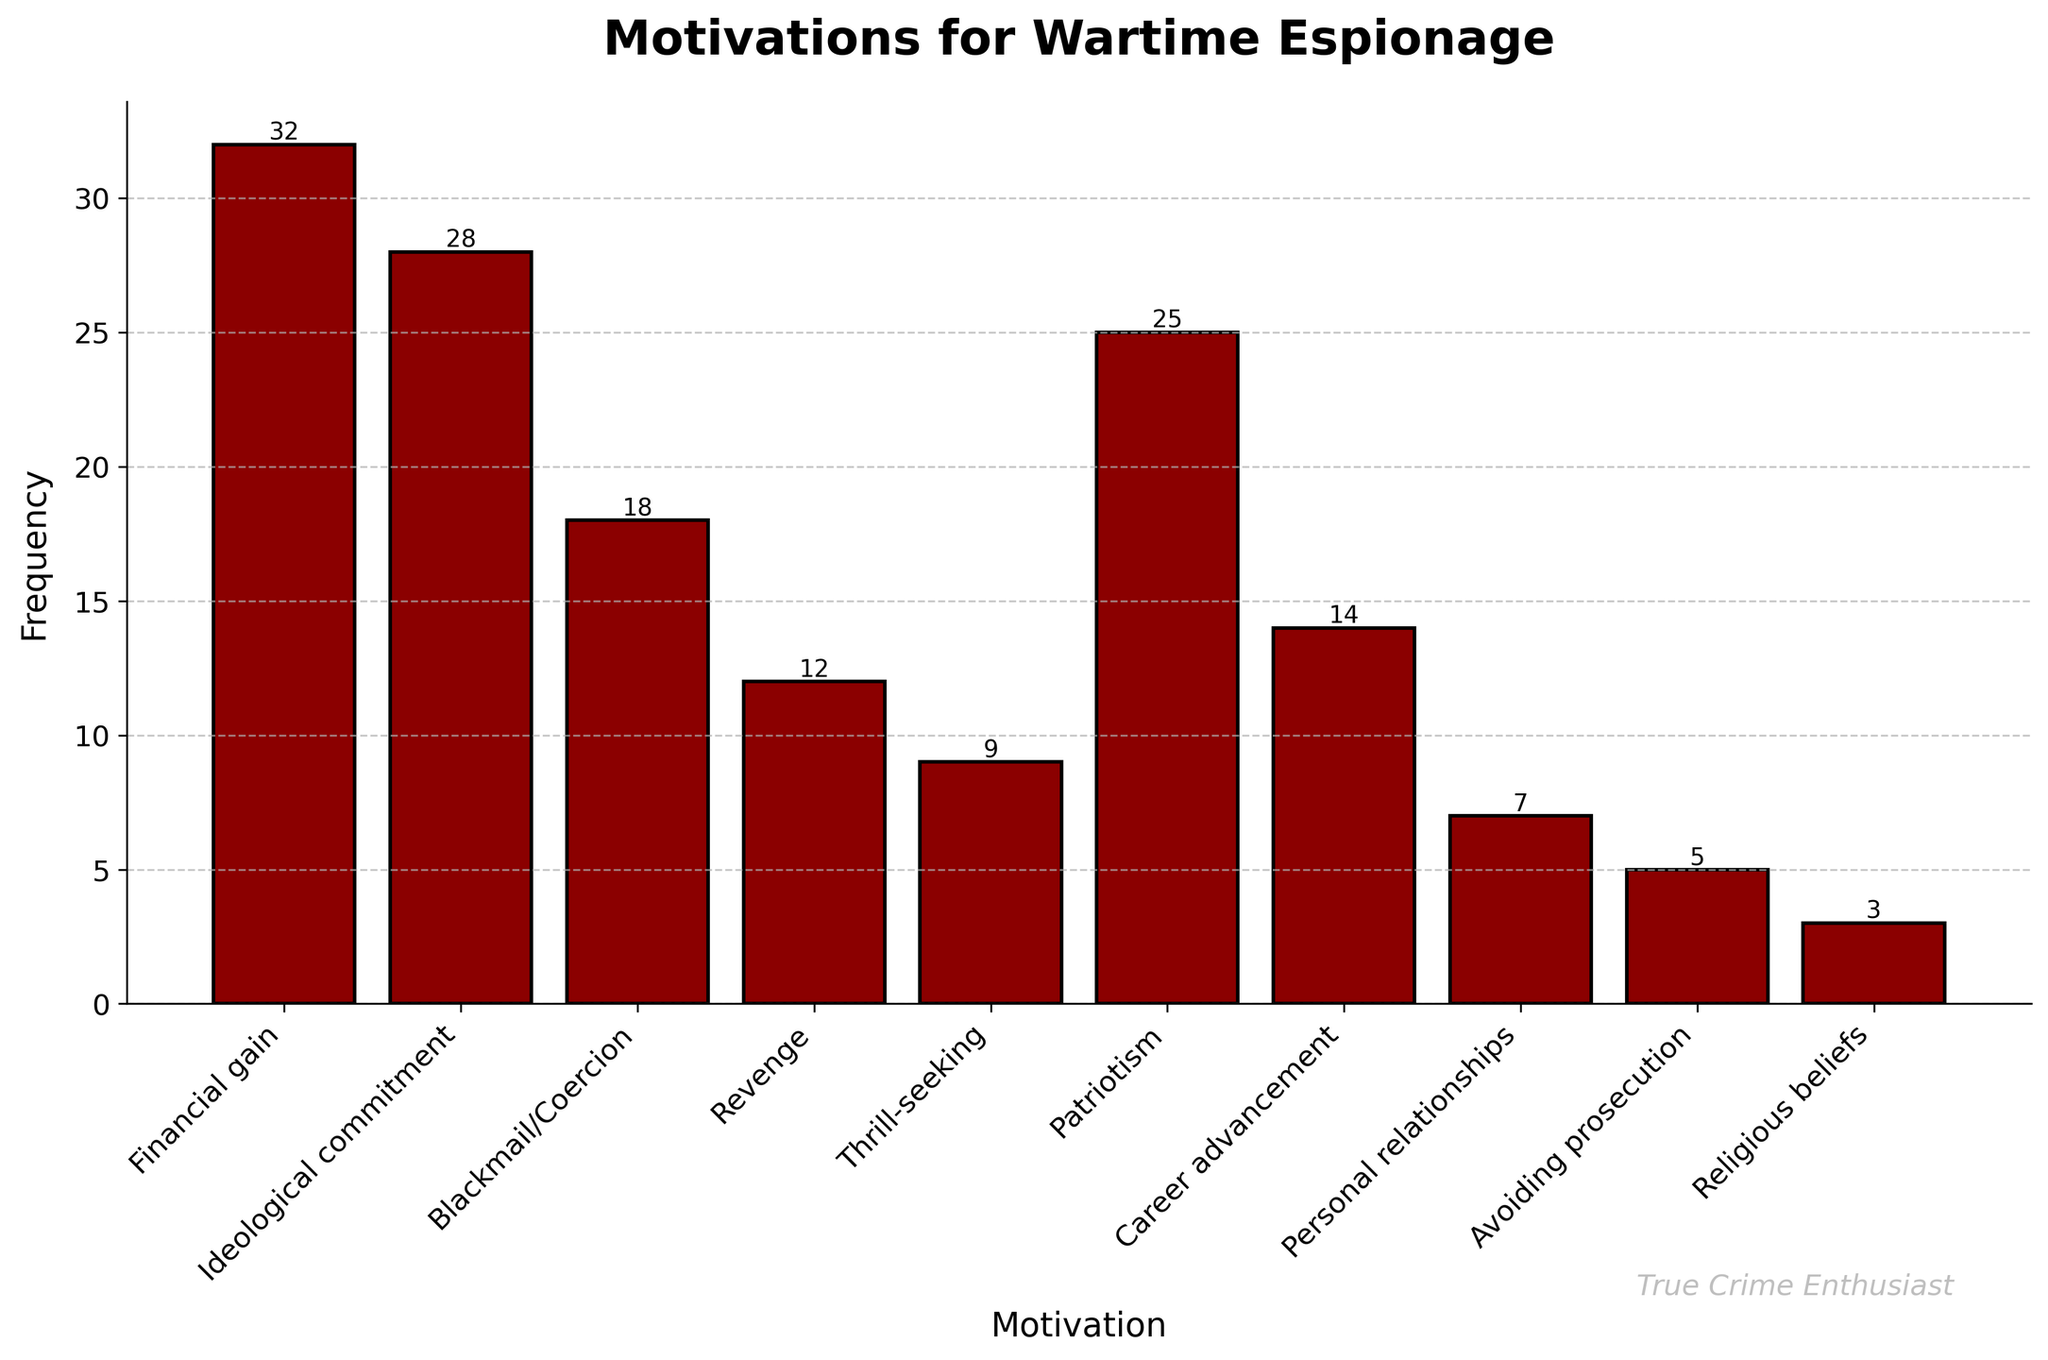Which motivation has the highest frequency? To find the motivation with the highest frequency, look at the tallest bar in the bar chart. The bar for "Financial gain" is the tallest, indicating it has the highest frequency.
Answer: Financial gain What is the combined frequency of "Revenge" and "Thrill-seeking"? To get the combined frequency, add the frequencies of "Revenge" (12) and "Thrill-seeking" (9). 12 + 9 = 21.
Answer: 21 Is the frequency for "Career advancement" more or less than "Blackmail/Coercion"? Compare the heights of the bars for "Career advancement" and "Blackmail/Coercion". The frequency for "Career advancement" is 14, which is less than the frequency for "Blackmail/Coercion" at 18.
Answer: Less Which has a lower frequency, "Avoiding prosecution" or "Personal relationships"? Compare the heights of the bars for "Avoiding prosecution" and "Personal relationships". "Avoiding prosecution" has a frequency of 5, which is less than "Personal relationships" with a frequency of 7.
Answer: Avoiding prosecution What is the difference in frequency between the highest and lowest motivations? Find the highest and lowest frequencies. "Financial gain" is highest at 32, and "Religious beliefs" is lowest at 3. Subtract the lowest from the highest: 32 - 3 = 29.
Answer: 29 How many motivations have a frequency higher than 20? Count the bars with a height greater than 20. "Financial gain" (32), "Ideological commitment" (28), and "Patriotism" (25) all have frequencies higher than 20, totaling 3 motivations.
Answer: 3 What's the average frequency for all motivations? Sum the frequencies of all motivations and divide by the number of motivations. (32 + 28 + 18 + 12 + 9 + 25 + 14 + 7 + 5 + 3) = 153. There are 10 motivations. 153 / 10 = 15.3.
Answer: 15.3 What color are the bars in the chart? The visual attribute of the bars, by observation, is a dark reddish color.
Answer: Dark red Does "Patriotism" have a higher frequency than "Revenge" plus "Personal relationships"? Compare the frequency of "Patriotism" (25) with the sum of "Revenge" (12) and "Personal relationships" (7). The sum is 12 + 7 = 19. Since 25 is greater than 19, "Patriotism" has a higher frequency.
Answer: Yes Which motivation has the smallest frequency? Look for the shortest bar in the chart, which corresponds to "Religious beliefs" with a frequency of 3.
Answer: Religious beliefs 